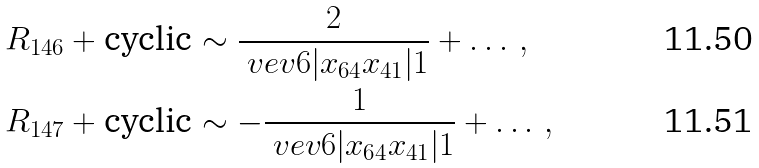Convert formula to latex. <formula><loc_0><loc_0><loc_500><loc_500>R _ { 1 4 6 } + \text {cyclic} & \sim \frac { 2 } { \ v e v { 6 | x _ { 6 4 } x _ { 4 1 } | 1 } } + \dots \, , \\ R _ { 1 4 7 } + \text {cyclic} & \sim - \frac { 1 } { \ v e v { 6 | x _ { 6 4 } x _ { 4 1 } | 1 } } + \dots \, ,</formula> 